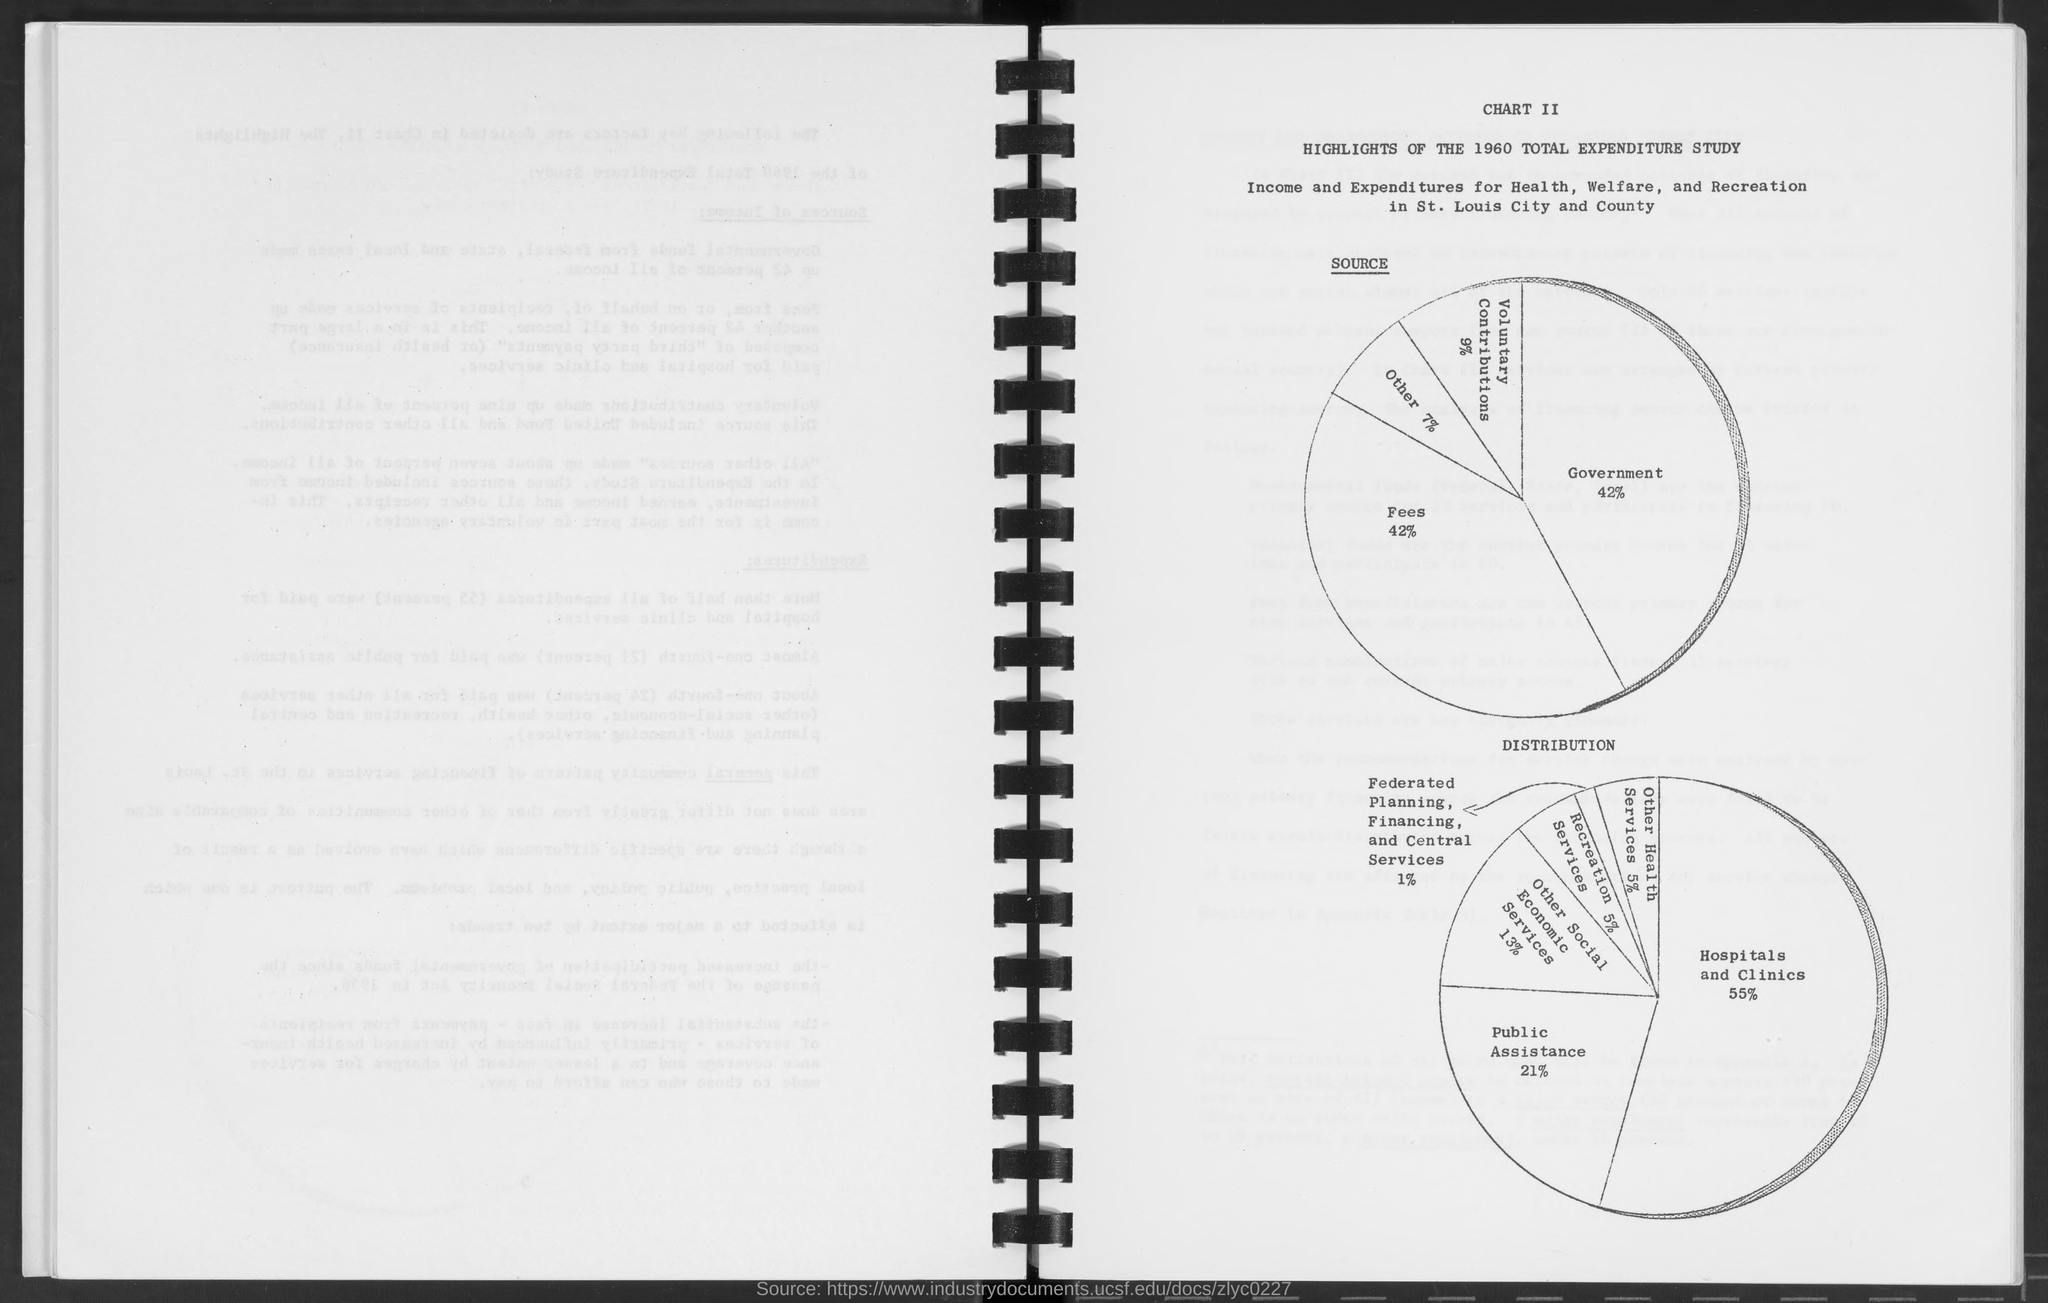what is the percentage for government in source as mentioned in the given page ? According to the information presented on the given page, the percentage allocated for government in the source of income for Health, Welfare, and Recreation in St. Louis City and County is 42%. 